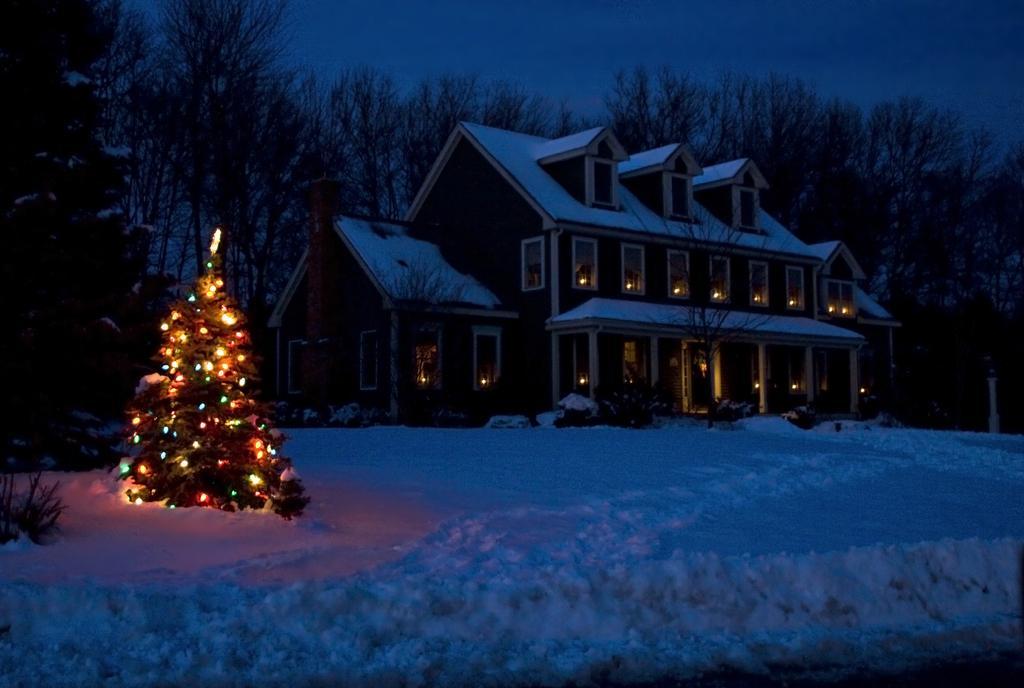Can you describe this image briefly? In the picture I can see a building and a Christmas tree decorated with lights. In the background I can see trees, the sky, the snow and some other objects. 